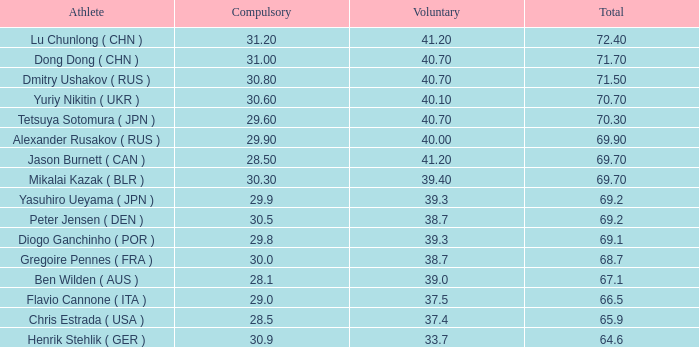2 and the optional is 3 0.0. 